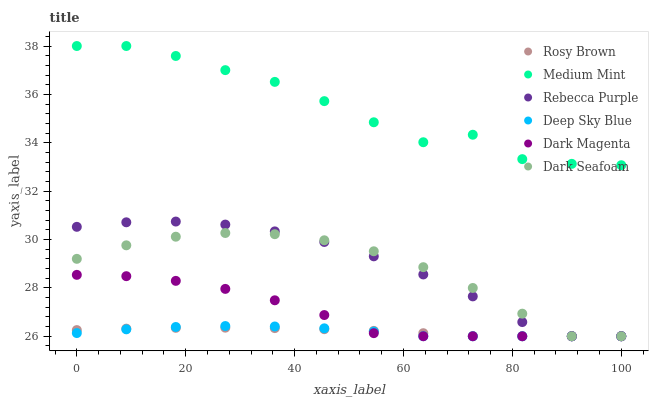Does Deep Sky Blue have the minimum area under the curve?
Answer yes or no. Yes. Does Medium Mint have the maximum area under the curve?
Answer yes or no. Yes. Does Dark Magenta have the minimum area under the curve?
Answer yes or no. No. Does Dark Magenta have the maximum area under the curve?
Answer yes or no. No. Is Rosy Brown the smoothest?
Answer yes or no. Yes. Is Medium Mint the roughest?
Answer yes or no. Yes. Is Dark Magenta the smoothest?
Answer yes or no. No. Is Dark Magenta the roughest?
Answer yes or no. No. Does Dark Magenta have the lowest value?
Answer yes or no. Yes. Does Medium Mint have the highest value?
Answer yes or no. Yes. Does Dark Magenta have the highest value?
Answer yes or no. No. Is Rebecca Purple less than Medium Mint?
Answer yes or no. Yes. Is Medium Mint greater than Deep Sky Blue?
Answer yes or no. Yes. Does Rebecca Purple intersect Dark Seafoam?
Answer yes or no. Yes. Is Rebecca Purple less than Dark Seafoam?
Answer yes or no. No. Is Rebecca Purple greater than Dark Seafoam?
Answer yes or no. No. Does Rebecca Purple intersect Medium Mint?
Answer yes or no. No. 